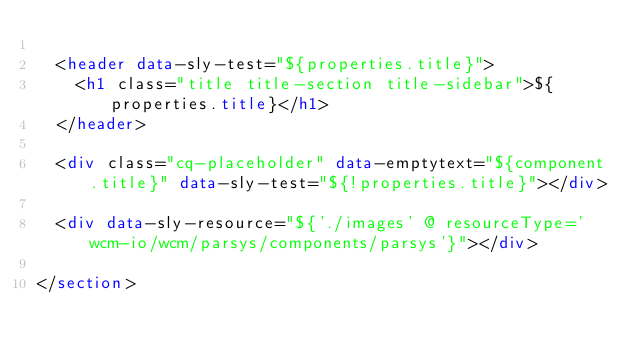Convert code to text. <code><loc_0><loc_0><loc_500><loc_500><_HTML_>
  <header data-sly-test="${properties.title}">
    <h1 class="title title-section title-sidebar">${properties.title}</h1>
  </header>

  <div class="cq-placeholder" data-emptytext="${component.title}" data-sly-test="${!properties.title}"></div>

  <div data-sly-resource="${'./images' @ resourceType='wcm-io/wcm/parsys/components/parsys'}"></div>

</section>
</code> 